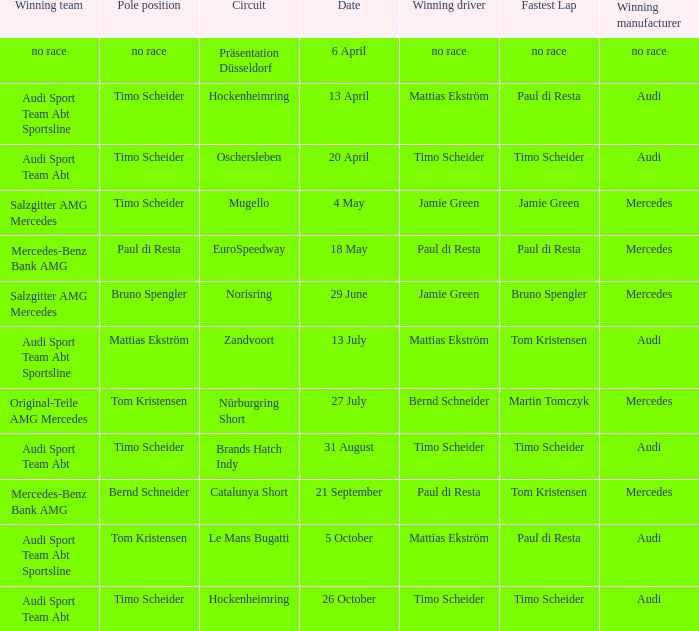Help me parse the entirety of this table. {'header': ['Winning team', 'Pole position', 'Circuit', 'Date', 'Winning driver', 'Fastest Lap', 'Winning manufacturer'], 'rows': [['no race', 'no race', 'Präsentation Düsseldorf', '6 April', 'no race', 'no race', 'no race'], ['Audi Sport Team Abt Sportsline', 'Timo Scheider', 'Hockenheimring', '13 April', 'Mattias Ekström', 'Paul di Resta', 'Audi'], ['Audi Sport Team Abt', 'Timo Scheider', 'Oschersleben', '20 April', 'Timo Scheider', 'Timo Scheider', 'Audi'], ['Salzgitter AMG Mercedes', 'Timo Scheider', 'Mugello', '4 May', 'Jamie Green', 'Jamie Green', 'Mercedes'], ['Mercedes-Benz Bank AMG', 'Paul di Resta', 'EuroSpeedway', '18 May', 'Paul di Resta', 'Paul di Resta', 'Mercedes'], ['Salzgitter AMG Mercedes', 'Bruno Spengler', 'Norisring', '29 June', 'Jamie Green', 'Bruno Spengler', 'Mercedes'], ['Audi Sport Team Abt Sportsline', 'Mattias Ekström', 'Zandvoort', '13 July', 'Mattias Ekström', 'Tom Kristensen', 'Audi'], ['Original-Teile AMG Mercedes', 'Tom Kristensen', 'Nürburgring Short', '27 July', 'Bernd Schneider', 'Martin Tomczyk', 'Mercedes'], ['Audi Sport Team Abt', 'Timo Scheider', 'Brands Hatch Indy', '31 August', 'Timo Scheider', 'Timo Scheider', 'Audi'], ['Mercedes-Benz Bank AMG', 'Bernd Schneider', 'Catalunya Short', '21 September', 'Paul di Resta', 'Tom Kristensen', 'Mercedes'], ['Audi Sport Team Abt Sportsline', 'Tom Kristensen', 'Le Mans Bugatti', '5 October', 'Mattias Ekström', 'Paul di Resta', 'Audi'], ['Audi Sport Team Abt', 'Timo Scheider', 'Hockenheimring', '26 October', 'Timo Scheider', 'Timo Scheider', 'Audi']]} Who is the winning driver of the Oschersleben circuit with Timo Scheider as the pole position? Timo Scheider. 